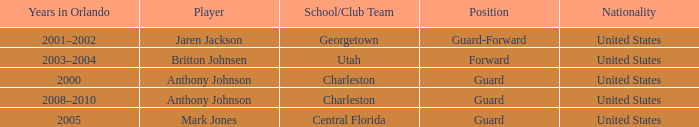Who was the Player that spent the Year 2005 in Orlando? Mark Jones. 